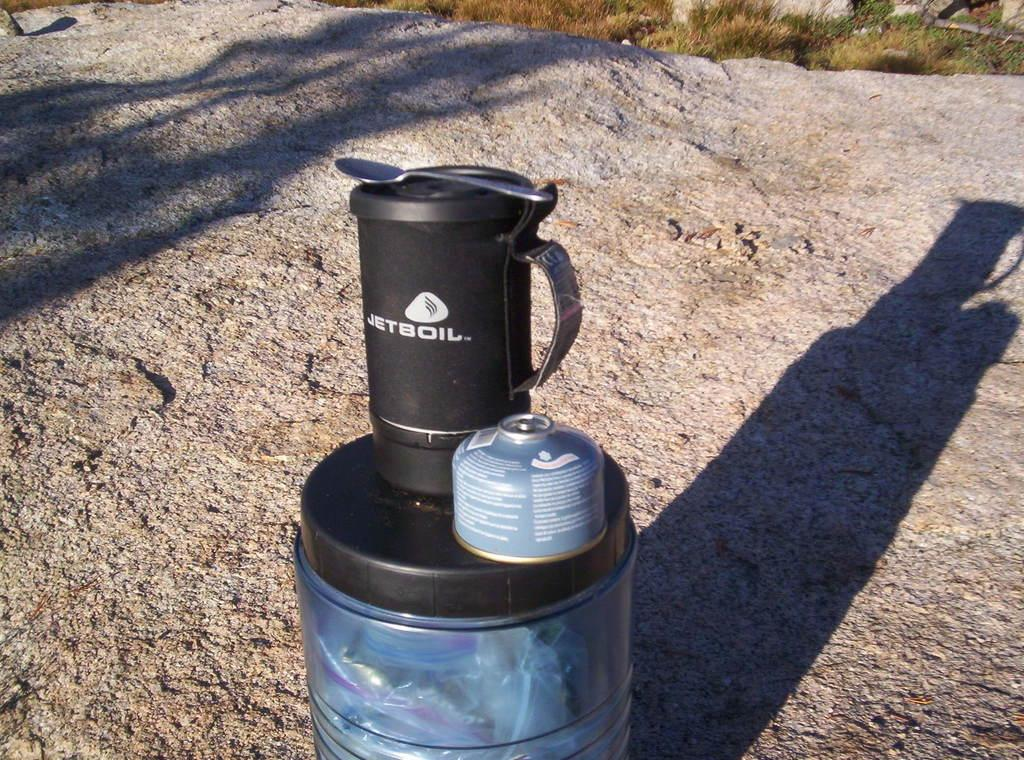<image>
Present a compact description of the photo's key features. A water bottle made by Jetboil rests on a rock outside. 